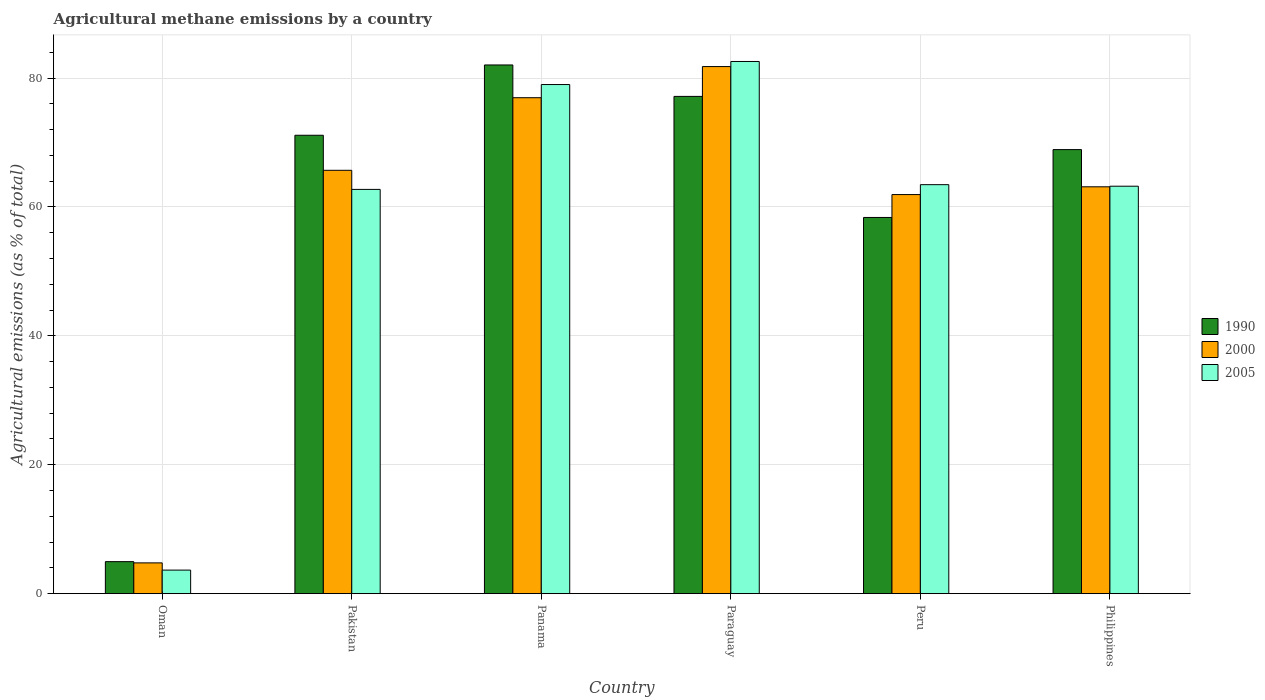How many groups of bars are there?
Keep it short and to the point. 6. Are the number of bars per tick equal to the number of legend labels?
Offer a very short reply. Yes. How many bars are there on the 6th tick from the right?
Give a very brief answer. 3. What is the label of the 5th group of bars from the left?
Your answer should be compact. Peru. In how many cases, is the number of bars for a given country not equal to the number of legend labels?
Offer a terse response. 0. What is the amount of agricultural methane emitted in 1990 in Pakistan?
Your answer should be very brief. 71.13. Across all countries, what is the maximum amount of agricultural methane emitted in 2000?
Your answer should be compact. 81.79. Across all countries, what is the minimum amount of agricultural methane emitted in 2005?
Make the answer very short. 3.66. In which country was the amount of agricultural methane emitted in 2005 maximum?
Offer a terse response. Paraguay. In which country was the amount of agricultural methane emitted in 2005 minimum?
Provide a short and direct response. Oman. What is the total amount of agricultural methane emitted in 1990 in the graph?
Provide a succinct answer. 362.58. What is the difference between the amount of agricultural methane emitted in 1990 in Paraguay and that in Philippines?
Give a very brief answer. 8.26. What is the difference between the amount of agricultural methane emitted in 2005 in Peru and the amount of agricultural methane emitted in 1990 in Panama?
Ensure brevity in your answer.  -18.58. What is the average amount of agricultural methane emitted in 2005 per country?
Your response must be concise. 59.11. What is the difference between the amount of agricultural methane emitted of/in 1990 and amount of agricultural methane emitted of/in 2000 in Oman?
Your answer should be compact. 0.19. What is the ratio of the amount of agricultural methane emitted in 2005 in Paraguay to that in Philippines?
Your answer should be very brief. 1.31. Is the amount of agricultural methane emitted in 1990 in Oman less than that in Peru?
Ensure brevity in your answer.  Yes. What is the difference between the highest and the second highest amount of agricultural methane emitted in 1990?
Your answer should be compact. 4.88. What is the difference between the highest and the lowest amount of agricultural methane emitted in 1990?
Offer a terse response. 77.07. In how many countries, is the amount of agricultural methane emitted in 2000 greater than the average amount of agricultural methane emitted in 2000 taken over all countries?
Your response must be concise. 5. Is the sum of the amount of agricultural methane emitted in 2005 in Panama and Philippines greater than the maximum amount of agricultural methane emitted in 1990 across all countries?
Keep it short and to the point. Yes. What does the 2nd bar from the left in Philippines represents?
Your answer should be compact. 2000. Is it the case that in every country, the sum of the amount of agricultural methane emitted in 2000 and amount of agricultural methane emitted in 1990 is greater than the amount of agricultural methane emitted in 2005?
Make the answer very short. Yes. How many bars are there?
Provide a succinct answer. 18. What is the difference between two consecutive major ticks on the Y-axis?
Provide a succinct answer. 20. Does the graph contain any zero values?
Keep it short and to the point. No. What is the title of the graph?
Offer a terse response. Agricultural methane emissions by a country. Does "2011" appear as one of the legend labels in the graph?
Your answer should be very brief. No. What is the label or title of the X-axis?
Provide a short and direct response. Country. What is the label or title of the Y-axis?
Your answer should be compact. Agricultural emissions (as % of total). What is the Agricultural emissions (as % of total) in 1990 in Oman?
Offer a very short reply. 4.97. What is the Agricultural emissions (as % of total) in 2000 in Oman?
Offer a terse response. 4.78. What is the Agricultural emissions (as % of total) in 2005 in Oman?
Your answer should be very brief. 3.66. What is the Agricultural emissions (as % of total) of 1990 in Pakistan?
Provide a succinct answer. 71.13. What is the Agricultural emissions (as % of total) in 2000 in Pakistan?
Provide a short and direct response. 65.69. What is the Agricultural emissions (as % of total) in 2005 in Pakistan?
Make the answer very short. 62.73. What is the Agricultural emissions (as % of total) of 1990 in Panama?
Your answer should be compact. 82.04. What is the Agricultural emissions (as % of total) in 2000 in Panama?
Give a very brief answer. 76.96. What is the Agricultural emissions (as % of total) of 2005 in Panama?
Offer a very short reply. 79. What is the Agricultural emissions (as % of total) of 1990 in Paraguay?
Make the answer very short. 77.16. What is the Agricultural emissions (as % of total) of 2000 in Paraguay?
Your answer should be compact. 81.79. What is the Agricultural emissions (as % of total) in 2005 in Paraguay?
Provide a short and direct response. 82.58. What is the Agricultural emissions (as % of total) in 1990 in Peru?
Give a very brief answer. 58.38. What is the Agricultural emissions (as % of total) of 2000 in Peru?
Offer a very short reply. 61.93. What is the Agricultural emissions (as % of total) in 2005 in Peru?
Offer a terse response. 63.46. What is the Agricultural emissions (as % of total) in 1990 in Philippines?
Give a very brief answer. 68.9. What is the Agricultural emissions (as % of total) of 2000 in Philippines?
Provide a succinct answer. 63.13. What is the Agricultural emissions (as % of total) in 2005 in Philippines?
Offer a very short reply. 63.22. Across all countries, what is the maximum Agricultural emissions (as % of total) of 1990?
Give a very brief answer. 82.04. Across all countries, what is the maximum Agricultural emissions (as % of total) in 2000?
Make the answer very short. 81.79. Across all countries, what is the maximum Agricultural emissions (as % of total) in 2005?
Make the answer very short. 82.58. Across all countries, what is the minimum Agricultural emissions (as % of total) of 1990?
Offer a terse response. 4.97. Across all countries, what is the minimum Agricultural emissions (as % of total) in 2000?
Ensure brevity in your answer.  4.78. Across all countries, what is the minimum Agricultural emissions (as % of total) in 2005?
Offer a terse response. 3.66. What is the total Agricultural emissions (as % of total) of 1990 in the graph?
Ensure brevity in your answer.  362.58. What is the total Agricultural emissions (as % of total) of 2000 in the graph?
Offer a terse response. 354.27. What is the total Agricultural emissions (as % of total) of 2005 in the graph?
Keep it short and to the point. 354.65. What is the difference between the Agricultural emissions (as % of total) of 1990 in Oman and that in Pakistan?
Ensure brevity in your answer.  -66.16. What is the difference between the Agricultural emissions (as % of total) in 2000 in Oman and that in Pakistan?
Ensure brevity in your answer.  -60.92. What is the difference between the Agricultural emissions (as % of total) of 2005 in Oman and that in Pakistan?
Keep it short and to the point. -59.07. What is the difference between the Agricultural emissions (as % of total) in 1990 in Oman and that in Panama?
Give a very brief answer. -77.07. What is the difference between the Agricultural emissions (as % of total) of 2000 in Oman and that in Panama?
Your response must be concise. -72.18. What is the difference between the Agricultural emissions (as % of total) in 2005 in Oman and that in Panama?
Your response must be concise. -75.35. What is the difference between the Agricultural emissions (as % of total) in 1990 in Oman and that in Paraguay?
Offer a very short reply. -72.19. What is the difference between the Agricultural emissions (as % of total) of 2000 in Oman and that in Paraguay?
Offer a terse response. -77.01. What is the difference between the Agricultural emissions (as % of total) in 2005 in Oman and that in Paraguay?
Your response must be concise. -78.92. What is the difference between the Agricultural emissions (as % of total) in 1990 in Oman and that in Peru?
Provide a short and direct response. -53.41. What is the difference between the Agricultural emissions (as % of total) of 2000 in Oman and that in Peru?
Make the answer very short. -57.15. What is the difference between the Agricultural emissions (as % of total) of 2005 in Oman and that in Peru?
Provide a short and direct response. -59.81. What is the difference between the Agricultural emissions (as % of total) of 1990 in Oman and that in Philippines?
Offer a terse response. -63.94. What is the difference between the Agricultural emissions (as % of total) in 2000 in Oman and that in Philippines?
Ensure brevity in your answer.  -58.35. What is the difference between the Agricultural emissions (as % of total) of 2005 in Oman and that in Philippines?
Provide a short and direct response. -59.57. What is the difference between the Agricultural emissions (as % of total) of 1990 in Pakistan and that in Panama?
Your answer should be compact. -10.91. What is the difference between the Agricultural emissions (as % of total) of 2000 in Pakistan and that in Panama?
Provide a short and direct response. -11.26. What is the difference between the Agricultural emissions (as % of total) in 2005 in Pakistan and that in Panama?
Offer a very short reply. -16.27. What is the difference between the Agricultural emissions (as % of total) of 1990 in Pakistan and that in Paraguay?
Your response must be concise. -6.03. What is the difference between the Agricultural emissions (as % of total) in 2000 in Pakistan and that in Paraguay?
Give a very brief answer. -16.1. What is the difference between the Agricultural emissions (as % of total) in 2005 in Pakistan and that in Paraguay?
Offer a very short reply. -19.85. What is the difference between the Agricultural emissions (as % of total) in 1990 in Pakistan and that in Peru?
Your response must be concise. 12.76. What is the difference between the Agricultural emissions (as % of total) of 2000 in Pakistan and that in Peru?
Your answer should be compact. 3.77. What is the difference between the Agricultural emissions (as % of total) of 2005 in Pakistan and that in Peru?
Your answer should be compact. -0.74. What is the difference between the Agricultural emissions (as % of total) of 1990 in Pakistan and that in Philippines?
Ensure brevity in your answer.  2.23. What is the difference between the Agricultural emissions (as % of total) of 2000 in Pakistan and that in Philippines?
Keep it short and to the point. 2.56. What is the difference between the Agricultural emissions (as % of total) in 2005 in Pakistan and that in Philippines?
Provide a succinct answer. -0.5. What is the difference between the Agricultural emissions (as % of total) in 1990 in Panama and that in Paraguay?
Make the answer very short. 4.88. What is the difference between the Agricultural emissions (as % of total) in 2000 in Panama and that in Paraguay?
Provide a short and direct response. -4.83. What is the difference between the Agricultural emissions (as % of total) in 2005 in Panama and that in Paraguay?
Make the answer very short. -3.58. What is the difference between the Agricultural emissions (as % of total) in 1990 in Panama and that in Peru?
Offer a very short reply. 23.66. What is the difference between the Agricultural emissions (as % of total) of 2000 in Panama and that in Peru?
Provide a succinct answer. 15.03. What is the difference between the Agricultural emissions (as % of total) of 2005 in Panama and that in Peru?
Your answer should be very brief. 15.54. What is the difference between the Agricultural emissions (as % of total) of 1990 in Panama and that in Philippines?
Ensure brevity in your answer.  13.14. What is the difference between the Agricultural emissions (as % of total) of 2000 in Panama and that in Philippines?
Ensure brevity in your answer.  13.83. What is the difference between the Agricultural emissions (as % of total) of 2005 in Panama and that in Philippines?
Provide a succinct answer. 15.78. What is the difference between the Agricultural emissions (as % of total) of 1990 in Paraguay and that in Peru?
Keep it short and to the point. 18.78. What is the difference between the Agricultural emissions (as % of total) of 2000 in Paraguay and that in Peru?
Provide a short and direct response. 19.86. What is the difference between the Agricultural emissions (as % of total) of 2005 in Paraguay and that in Peru?
Your response must be concise. 19.11. What is the difference between the Agricultural emissions (as % of total) of 1990 in Paraguay and that in Philippines?
Provide a short and direct response. 8.26. What is the difference between the Agricultural emissions (as % of total) of 2000 in Paraguay and that in Philippines?
Offer a terse response. 18.66. What is the difference between the Agricultural emissions (as % of total) of 2005 in Paraguay and that in Philippines?
Provide a succinct answer. 19.35. What is the difference between the Agricultural emissions (as % of total) in 1990 in Peru and that in Philippines?
Offer a very short reply. -10.53. What is the difference between the Agricultural emissions (as % of total) in 2000 in Peru and that in Philippines?
Your answer should be compact. -1.2. What is the difference between the Agricultural emissions (as % of total) of 2005 in Peru and that in Philippines?
Make the answer very short. 0.24. What is the difference between the Agricultural emissions (as % of total) of 1990 in Oman and the Agricultural emissions (as % of total) of 2000 in Pakistan?
Your response must be concise. -60.73. What is the difference between the Agricultural emissions (as % of total) in 1990 in Oman and the Agricultural emissions (as % of total) in 2005 in Pakistan?
Offer a very short reply. -57.76. What is the difference between the Agricultural emissions (as % of total) in 2000 in Oman and the Agricultural emissions (as % of total) in 2005 in Pakistan?
Your answer should be very brief. -57.95. What is the difference between the Agricultural emissions (as % of total) of 1990 in Oman and the Agricultural emissions (as % of total) of 2000 in Panama?
Ensure brevity in your answer.  -71.99. What is the difference between the Agricultural emissions (as % of total) of 1990 in Oman and the Agricultural emissions (as % of total) of 2005 in Panama?
Provide a short and direct response. -74.03. What is the difference between the Agricultural emissions (as % of total) of 2000 in Oman and the Agricultural emissions (as % of total) of 2005 in Panama?
Your answer should be very brief. -74.23. What is the difference between the Agricultural emissions (as % of total) in 1990 in Oman and the Agricultural emissions (as % of total) in 2000 in Paraguay?
Your response must be concise. -76.82. What is the difference between the Agricultural emissions (as % of total) of 1990 in Oman and the Agricultural emissions (as % of total) of 2005 in Paraguay?
Offer a very short reply. -77.61. What is the difference between the Agricultural emissions (as % of total) in 2000 in Oman and the Agricultural emissions (as % of total) in 2005 in Paraguay?
Make the answer very short. -77.8. What is the difference between the Agricultural emissions (as % of total) in 1990 in Oman and the Agricultural emissions (as % of total) in 2000 in Peru?
Your response must be concise. -56.96. What is the difference between the Agricultural emissions (as % of total) in 1990 in Oman and the Agricultural emissions (as % of total) in 2005 in Peru?
Keep it short and to the point. -58.5. What is the difference between the Agricultural emissions (as % of total) of 2000 in Oman and the Agricultural emissions (as % of total) of 2005 in Peru?
Your answer should be compact. -58.69. What is the difference between the Agricultural emissions (as % of total) in 1990 in Oman and the Agricultural emissions (as % of total) in 2000 in Philippines?
Your answer should be compact. -58.16. What is the difference between the Agricultural emissions (as % of total) in 1990 in Oman and the Agricultural emissions (as % of total) in 2005 in Philippines?
Offer a very short reply. -58.26. What is the difference between the Agricultural emissions (as % of total) in 2000 in Oman and the Agricultural emissions (as % of total) in 2005 in Philippines?
Make the answer very short. -58.45. What is the difference between the Agricultural emissions (as % of total) of 1990 in Pakistan and the Agricultural emissions (as % of total) of 2000 in Panama?
Your answer should be very brief. -5.83. What is the difference between the Agricultural emissions (as % of total) of 1990 in Pakistan and the Agricultural emissions (as % of total) of 2005 in Panama?
Offer a terse response. -7.87. What is the difference between the Agricultural emissions (as % of total) of 2000 in Pakistan and the Agricultural emissions (as % of total) of 2005 in Panama?
Your answer should be very brief. -13.31. What is the difference between the Agricultural emissions (as % of total) in 1990 in Pakistan and the Agricultural emissions (as % of total) in 2000 in Paraguay?
Your answer should be compact. -10.66. What is the difference between the Agricultural emissions (as % of total) of 1990 in Pakistan and the Agricultural emissions (as % of total) of 2005 in Paraguay?
Provide a succinct answer. -11.45. What is the difference between the Agricultural emissions (as % of total) in 2000 in Pakistan and the Agricultural emissions (as % of total) in 2005 in Paraguay?
Offer a very short reply. -16.89. What is the difference between the Agricultural emissions (as % of total) of 1990 in Pakistan and the Agricultural emissions (as % of total) of 2000 in Peru?
Your answer should be very brief. 9.2. What is the difference between the Agricultural emissions (as % of total) of 1990 in Pakistan and the Agricultural emissions (as % of total) of 2005 in Peru?
Your answer should be compact. 7.67. What is the difference between the Agricultural emissions (as % of total) of 2000 in Pakistan and the Agricultural emissions (as % of total) of 2005 in Peru?
Your answer should be very brief. 2.23. What is the difference between the Agricultural emissions (as % of total) in 1990 in Pakistan and the Agricultural emissions (as % of total) in 2000 in Philippines?
Provide a succinct answer. 8. What is the difference between the Agricultural emissions (as % of total) in 1990 in Pakistan and the Agricultural emissions (as % of total) in 2005 in Philippines?
Your answer should be very brief. 7.91. What is the difference between the Agricultural emissions (as % of total) in 2000 in Pakistan and the Agricultural emissions (as % of total) in 2005 in Philippines?
Your answer should be very brief. 2.47. What is the difference between the Agricultural emissions (as % of total) of 1990 in Panama and the Agricultural emissions (as % of total) of 2000 in Paraguay?
Give a very brief answer. 0.25. What is the difference between the Agricultural emissions (as % of total) in 1990 in Panama and the Agricultural emissions (as % of total) in 2005 in Paraguay?
Provide a succinct answer. -0.54. What is the difference between the Agricultural emissions (as % of total) in 2000 in Panama and the Agricultural emissions (as % of total) in 2005 in Paraguay?
Ensure brevity in your answer.  -5.62. What is the difference between the Agricultural emissions (as % of total) in 1990 in Panama and the Agricultural emissions (as % of total) in 2000 in Peru?
Keep it short and to the point. 20.11. What is the difference between the Agricultural emissions (as % of total) of 1990 in Panama and the Agricultural emissions (as % of total) of 2005 in Peru?
Keep it short and to the point. 18.58. What is the difference between the Agricultural emissions (as % of total) of 2000 in Panama and the Agricultural emissions (as % of total) of 2005 in Peru?
Ensure brevity in your answer.  13.49. What is the difference between the Agricultural emissions (as % of total) in 1990 in Panama and the Agricultural emissions (as % of total) in 2000 in Philippines?
Your answer should be compact. 18.91. What is the difference between the Agricultural emissions (as % of total) in 1990 in Panama and the Agricultural emissions (as % of total) in 2005 in Philippines?
Your answer should be compact. 18.81. What is the difference between the Agricultural emissions (as % of total) of 2000 in Panama and the Agricultural emissions (as % of total) of 2005 in Philippines?
Provide a short and direct response. 13.73. What is the difference between the Agricultural emissions (as % of total) of 1990 in Paraguay and the Agricultural emissions (as % of total) of 2000 in Peru?
Your answer should be very brief. 15.23. What is the difference between the Agricultural emissions (as % of total) of 1990 in Paraguay and the Agricultural emissions (as % of total) of 2005 in Peru?
Offer a very short reply. 13.7. What is the difference between the Agricultural emissions (as % of total) of 2000 in Paraguay and the Agricultural emissions (as % of total) of 2005 in Peru?
Make the answer very short. 18.33. What is the difference between the Agricultural emissions (as % of total) of 1990 in Paraguay and the Agricultural emissions (as % of total) of 2000 in Philippines?
Your answer should be very brief. 14.03. What is the difference between the Agricultural emissions (as % of total) of 1990 in Paraguay and the Agricultural emissions (as % of total) of 2005 in Philippines?
Ensure brevity in your answer.  13.94. What is the difference between the Agricultural emissions (as % of total) in 2000 in Paraguay and the Agricultural emissions (as % of total) in 2005 in Philippines?
Give a very brief answer. 18.57. What is the difference between the Agricultural emissions (as % of total) in 1990 in Peru and the Agricultural emissions (as % of total) in 2000 in Philippines?
Make the answer very short. -4.76. What is the difference between the Agricultural emissions (as % of total) in 1990 in Peru and the Agricultural emissions (as % of total) in 2005 in Philippines?
Your answer should be compact. -4.85. What is the difference between the Agricultural emissions (as % of total) in 2000 in Peru and the Agricultural emissions (as % of total) in 2005 in Philippines?
Give a very brief answer. -1.3. What is the average Agricultural emissions (as % of total) in 1990 per country?
Your answer should be compact. 60.43. What is the average Agricultural emissions (as % of total) of 2000 per country?
Your response must be concise. 59.05. What is the average Agricultural emissions (as % of total) in 2005 per country?
Ensure brevity in your answer.  59.11. What is the difference between the Agricultural emissions (as % of total) of 1990 and Agricultural emissions (as % of total) of 2000 in Oman?
Provide a succinct answer. 0.19. What is the difference between the Agricultural emissions (as % of total) of 1990 and Agricultural emissions (as % of total) of 2005 in Oman?
Your answer should be very brief. 1.31. What is the difference between the Agricultural emissions (as % of total) in 2000 and Agricultural emissions (as % of total) in 2005 in Oman?
Provide a short and direct response. 1.12. What is the difference between the Agricultural emissions (as % of total) in 1990 and Agricultural emissions (as % of total) in 2000 in Pakistan?
Ensure brevity in your answer.  5.44. What is the difference between the Agricultural emissions (as % of total) of 1990 and Agricultural emissions (as % of total) of 2005 in Pakistan?
Provide a short and direct response. 8.4. What is the difference between the Agricultural emissions (as % of total) of 2000 and Agricultural emissions (as % of total) of 2005 in Pakistan?
Offer a terse response. 2.96. What is the difference between the Agricultural emissions (as % of total) in 1990 and Agricultural emissions (as % of total) in 2000 in Panama?
Offer a very short reply. 5.08. What is the difference between the Agricultural emissions (as % of total) of 1990 and Agricultural emissions (as % of total) of 2005 in Panama?
Provide a short and direct response. 3.04. What is the difference between the Agricultural emissions (as % of total) in 2000 and Agricultural emissions (as % of total) in 2005 in Panama?
Make the answer very short. -2.04. What is the difference between the Agricultural emissions (as % of total) in 1990 and Agricultural emissions (as % of total) in 2000 in Paraguay?
Offer a terse response. -4.63. What is the difference between the Agricultural emissions (as % of total) of 1990 and Agricultural emissions (as % of total) of 2005 in Paraguay?
Give a very brief answer. -5.42. What is the difference between the Agricultural emissions (as % of total) of 2000 and Agricultural emissions (as % of total) of 2005 in Paraguay?
Offer a very short reply. -0.79. What is the difference between the Agricultural emissions (as % of total) in 1990 and Agricultural emissions (as % of total) in 2000 in Peru?
Your answer should be compact. -3.55. What is the difference between the Agricultural emissions (as % of total) of 1990 and Agricultural emissions (as % of total) of 2005 in Peru?
Provide a succinct answer. -5.09. What is the difference between the Agricultural emissions (as % of total) of 2000 and Agricultural emissions (as % of total) of 2005 in Peru?
Offer a very short reply. -1.54. What is the difference between the Agricultural emissions (as % of total) in 1990 and Agricultural emissions (as % of total) in 2000 in Philippines?
Offer a terse response. 5.77. What is the difference between the Agricultural emissions (as % of total) in 1990 and Agricultural emissions (as % of total) in 2005 in Philippines?
Your response must be concise. 5.68. What is the difference between the Agricultural emissions (as % of total) of 2000 and Agricultural emissions (as % of total) of 2005 in Philippines?
Provide a succinct answer. -0.09. What is the ratio of the Agricultural emissions (as % of total) in 1990 in Oman to that in Pakistan?
Provide a short and direct response. 0.07. What is the ratio of the Agricultural emissions (as % of total) of 2000 in Oman to that in Pakistan?
Ensure brevity in your answer.  0.07. What is the ratio of the Agricultural emissions (as % of total) of 2005 in Oman to that in Pakistan?
Provide a short and direct response. 0.06. What is the ratio of the Agricultural emissions (as % of total) in 1990 in Oman to that in Panama?
Make the answer very short. 0.06. What is the ratio of the Agricultural emissions (as % of total) in 2000 in Oman to that in Panama?
Offer a very short reply. 0.06. What is the ratio of the Agricultural emissions (as % of total) in 2005 in Oman to that in Panama?
Ensure brevity in your answer.  0.05. What is the ratio of the Agricultural emissions (as % of total) of 1990 in Oman to that in Paraguay?
Your response must be concise. 0.06. What is the ratio of the Agricultural emissions (as % of total) of 2000 in Oman to that in Paraguay?
Your answer should be compact. 0.06. What is the ratio of the Agricultural emissions (as % of total) of 2005 in Oman to that in Paraguay?
Ensure brevity in your answer.  0.04. What is the ratio of the Agricultural emissions (as % of total) of 1990 in Oman to that in Peru?
Your answer should be very brief. 0.09. What is the ratio of the Agricultural emissions (as % of total) in 2000 in Oman to that in Peru?
Your answer should be compact. 0.08. What is the ratio of the Agricultural emissions (as % of total) of 2005 in Oman to that in Peru?
Make the answer very short. 0.06. What is the ratio of the Agricultural emissions (as % of total) in 1990 in Oman to that in Philippines?
Offer a terse response. 0.07. What is the ratio of the Agricultural emissions (as % of total) in 2000 in Oman to that in Philippines?
Offer a terse response. 0.08. What is the ratio of the Agricultural emissions (as % of total) of 2005 in Oman to that in Philippines?
Keep it short and to the point. 0.06. What is the ratio of the Agricultural emissions (as % of total) in 1990 in Pakistan to that in Panama?
Your response must be concise. 0.87. What is the ratio of the Agricultural emissions (as % of total) of 2000 in Pakistan to that in Panama?
Provide a succinct answer. 0.85. What is the ratio of the Agricultural emissions (as % of total) in 2005 in Pakistan to that in Panama?
Offer a very short reply. 0.79. What is the ratio of the Agricultural emissions (as % of total) of 1990 in Pakistan to that in Paraguay?
Offer a very short reply. 0.92. What is the ratio of the Agricultural emissions (as % of total) of 2000 in Pakistan to that in Paraguay?
Make the answer very short. 0.8. What is the ratio of the Agricultural emissions (as % of total) in 2005 in Pakistan to that in Paraguay?
Make the answer very short. 0.76. What is the ratio of the Agricultural emissions (as % of total) in 1990 in Pakistan to that in Peru?
Your response must be concise. 1.22. What is the ratio of the Agricultural emissions (as % of total) in 2000 in Pakistan to that in Peru?
Your answer should be compact. 1.06. What is the ratio of the Agricultural emissions (as % of total) in 2005 in Pakistan to that in Peru?
Offer a terse response. 0.99. What is the ratio of the Agricultural emissions (as % of total) in 1990 in Pakistan to that in Philippines?
Your response must be concise. 1.03. What is the ratio of the Agricultural emissions (as % of total) of 2000 in Pakistan to that in Philippines?
Your answer should be very brief. 1.04. What is the ratio of the Agricultural emissions (as % of total) in 1990 in Panama to that in Paraguay?
Give a very brief answer. 1.06. What is the ratio of the Agricultural emissions (as % of total) of 2000 in Panama to that in Paraguay?
Offer a terse response. 0.94. What is the ratio of the Agricultural emissions (as % of total) in 2005 in Panama to that in Paraguay?
Give a very brief answer. 0.96. What is the ratio of the Agricultural emissions (as % of total) of 1990 in Panama to that in Peru?
Provide a succinct answer. 1.41. What is the ratio of the Agricultural emissions (as % of total) of 2000 in Panama to that in Peru?
Your response must be concise. 1.24. What is the ratio of the Agricultural emissions (as % of total) of 2005 in Panama to that in Peru?
Offer a terse response. 1.24. What is the ratio of the Agricultural emissions (as % of total) of 1990 in Panama to that in Philippines?
Keep it short and to the point. 1.19. What is the ratio of the Agricultural emissions (as % of total) of 2000 in Panama to that in Philippines?
Provide a short and direct response. 1.22. What is the ratio of the Agricultural emissions (as % of total) in 2005 in Panama to that in Philippines?
Your response must be concise. 1.25. What is the ratio of the Agricultural emissions (as % of total) in 1990 in Paraguay to that in Peru?
Give a very brief answer. 1.32. What is the ratio of the Agricultural emissions (as % of total) of 2000 in Paraguay to that in Peru?
Your response must be concise. 1.32. What is the ratio of the Agricultural emissions (as % of total) of 2005 in Paraguay to that in Peru?
Ensure brevity in your answer.  1.3. What is the ratio of the Agricultural emissions (as % of total) of 1990 in Paraguay to that in Philippines?
Keep it short and to the point. 1.12. What is the ratio of the Agricultural emissions (as % of total) in 2000 in Paraguay to that in Philippines?
Give a very brief answer. 1.3. What is the ratio of the Agricultural emissions (as % of total) in 2005 in Paraguay to that in Philippines?
Keep it short and to the point. 1.31. What is the ratio of the Agricultural emissions (as % of total) in 1990 in Peru to that in Philippines?
Offer a very short reply. 0.85. What is the ratio of the Agricultural emissions (as % of total) in 2000 in Peru to that in Philippines?
Your response must be concise. 0.98. What is the ratio of the Agricultural emissions (as % of total) in 2005 in Peru to that in Philippines?
Offer a very short reply. 1. What is the difference between the highest and the second highest Agricultural emissions (as % of total) in 1990?
Offer a very short reply. 4.88. What is the difference between the highest and the second highest Agricultural emissions (as % of total) in 2000?
Your response must be concise. 4.83. What is the difference between the highest and the second highest Agricultural emissions (as % of total) in 2005?
Keep it short and to the point. 3.58. What is the difference between the highest and the lowest Agricultural emissions (as % of total) of 1990?
Offer a terse response. 77.07. What is the difference between the highest and the lowest Agricultural emissions (as % of total) of 2000?
Keep it short and to the point. 77.01. What is the difference between the highest and the lowest Agricultural emissions (as % of total) in 2005?
Offer a terse response. 78.92. 